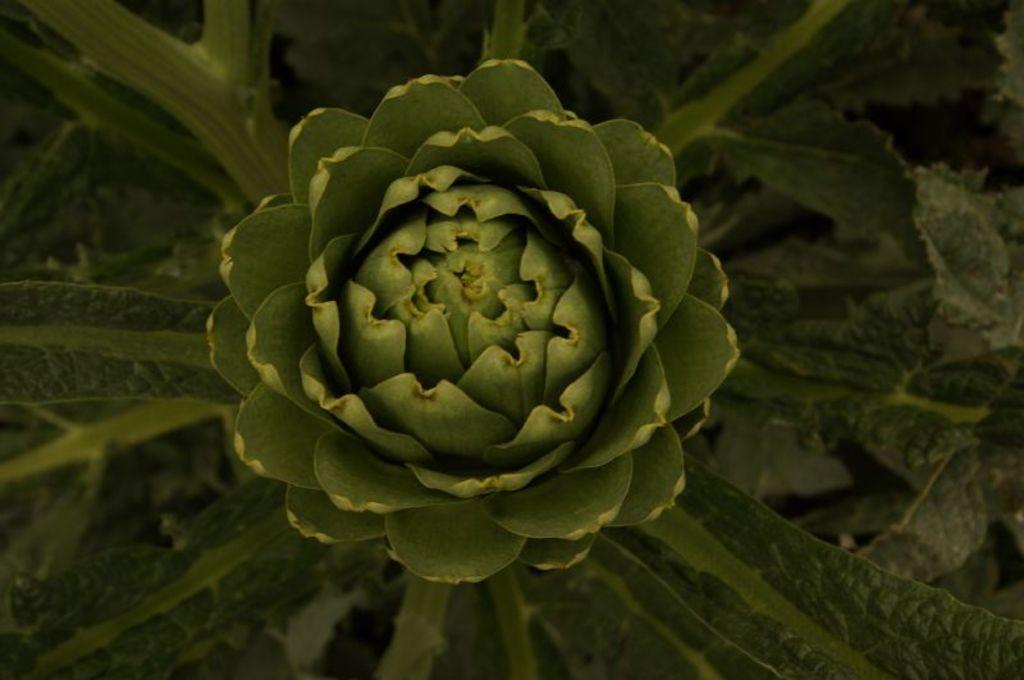What type of living organisms can be seen in the image? Plants can be seen in the image. Are there any specific features on the plants? Yes, there is a flower on one of the plants. What type of class is being held in the image? There is no class or any indication of a class being held in the image. 